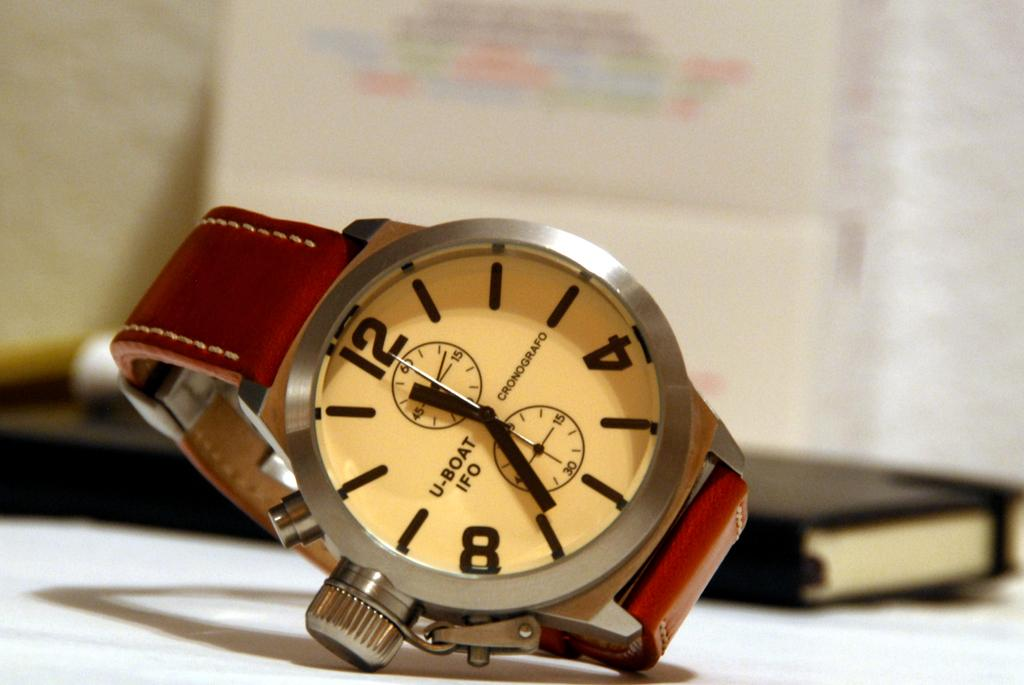<image>
Share a concise interpretation of the image provided. a close up of a U Boat IFO wrist watch on a table 